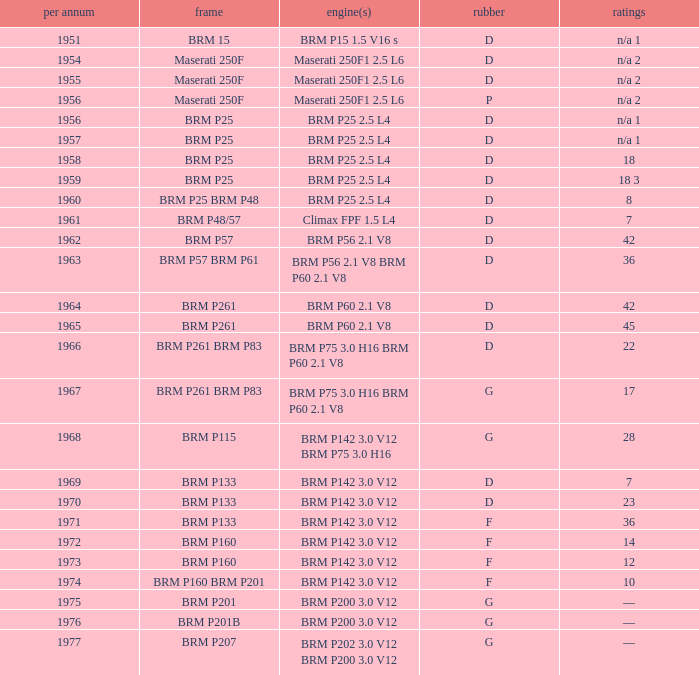Name the point for 1974 10.0. 